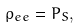<formula> <loc_0><loc_0><loc_500><loc_500>\rho _ { e e } = P _ { S } ,</formula> 